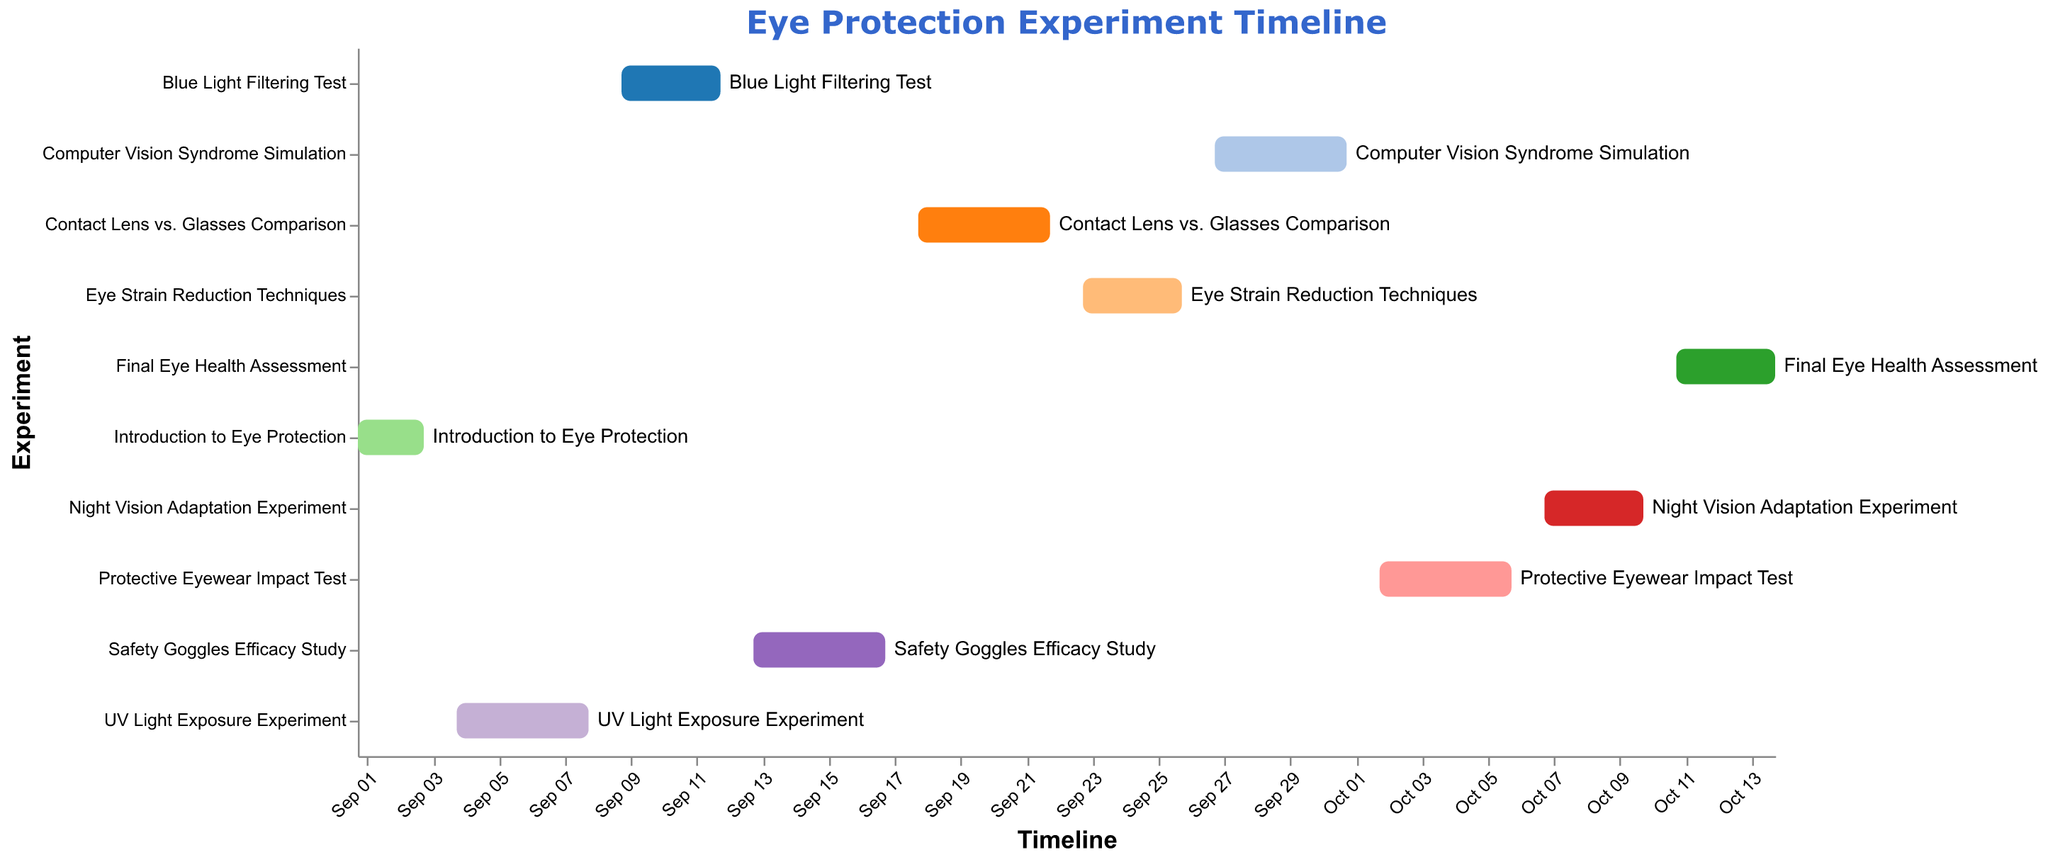How long did the "Safety Goggles Efficacy Study" last? By looking at the start and end dates of the "Safety Goggles Efficacy Study" task in the Gantt chart, we see that it started on September 13 and ended on September 17, totaling 5 days.
Answer: 5 days Which experiment started immediately after the "UV Light Exposure Experiment"? According to the sequence in the Gantt chart, the "Blue Light Filtering Test" started on September 9, right after the "UV Light Exposure Experiment" ended on September 8.
Answer: Blue Light Filtering Test What is the total duration of the "Computer Vision Syndrome Simulation" experiment? The "Computer Vision Syndrome Simulation" started on September 27 and ended on October 1. Calculating the duration between these dates, we find it lasted 5 days.
Answer: 5 days Which task lasted the longest, and for how many days? By comparing the start and end dates of all tasks, the "UV Light Exposure Experiment" lasted the longest, spanning from September 4 to September 8, which is 5 days.
Answer: UV Light Exposure Experiment, 5 days When did the "Final Eye Health Assessment" begin and end? The "Final Eye Health Assessment" started on October 11 and ended on October 14, as shown in the Gantt chart.
Answer: October 11, October 14 List the experiments conducted during the month of September. By checking the Gantt chart, the experiments conducted in September are "Introduction to Eye Protection", "UV Light Exposure Experiment", "Blue Light Filtering Test", "Safety Goggles Efficacy Study", "Contact Lens vs. Glasses Comparison", "Eye Strain Reduction Techniques", "Computer Vision Syndrome Simulation".
Answer: Introduction to Eye Protection, UV Light Exposure Experiment, Blue Light Filtering Test, Safety Goggles Efficacy Study, Contact Lens vs. Glasses Comparison, Eye Strain Reduction Techniques, Computer Vision Syndrome Simulation Which experiments overlap with the "Contact Lens vs. Glasses Comparison"? The "Contact Lens vs. Glasses Comparison" took place from September 18 to September 22. The "Safety Goggles Efficacy Study" ended on September 17, and the "Eye Strain Reduction Techniques" started on September 23, hence no experiments overlap with it.
Answer: None How many experiments have a duration of exactly 4 days? By examining the Gantt chart for experiments that lasted 4 days, "Blue Light Filtering Test" (September 9 to 12), "Protective Eyewear Impact Test" (October 2 to 6), and "Night Vision Adaptation Experiment" (October 7 to 10) each lasted exactly 4 days.
Answer: 3 Are there any tasks that end on the same day another task begins? By inspecting the Gantt chart, there are no tasks that share this overlap where one ends on the same day another begins.
Answer: No 